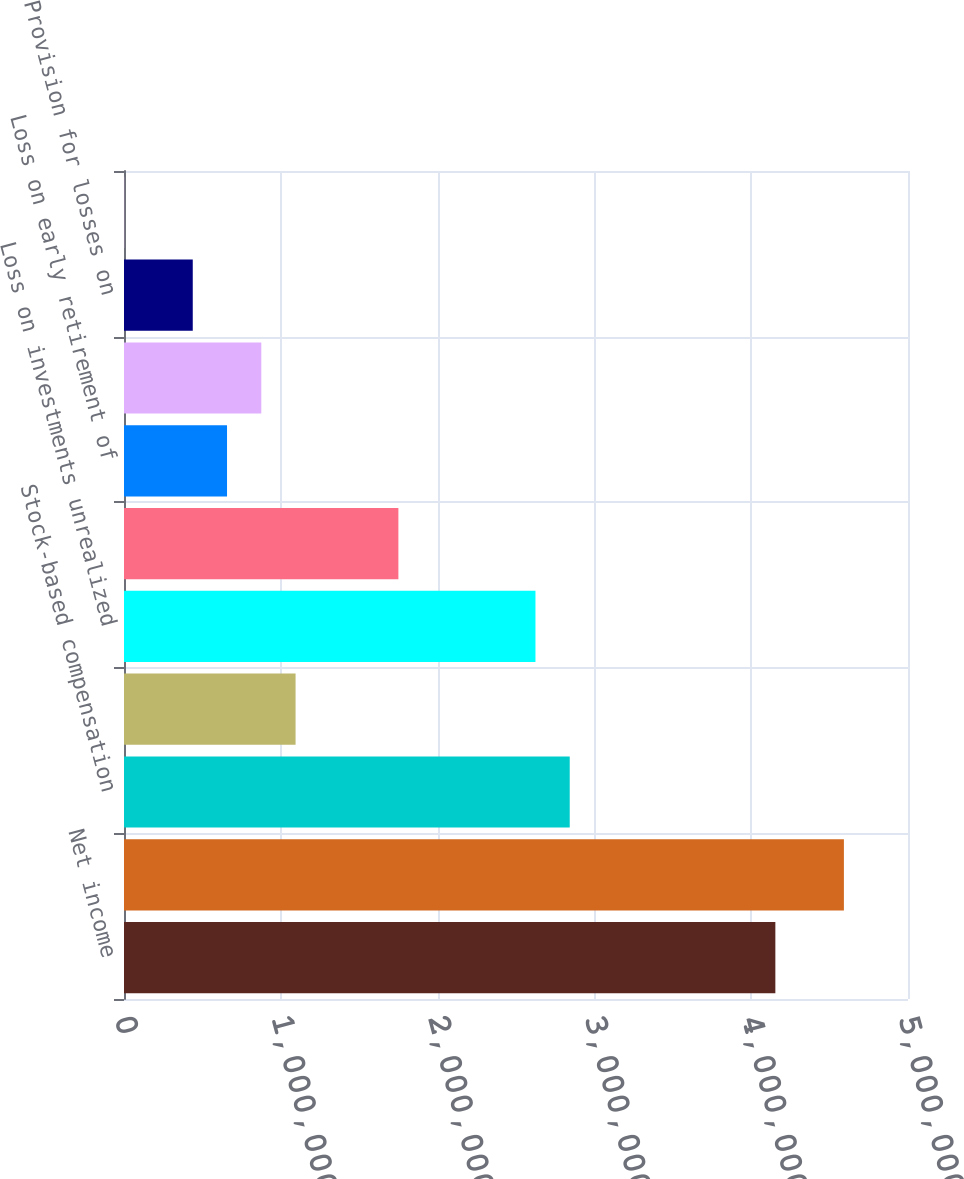Convert chart. <chart><loc_0><loc_0><loc_500><loc_500><bar_chart><fcel>Net income<fcel>Depreciation amortization and<fcel>Stock-based compensation<fcel>Decrease (increase) in<fcel>Loss on investments unrealized<fcel>expenses<fcel>Loss on early retirement of<fcel>interest<fcel>Provision for losses on<fcel>Deferred income taxes<nl><fcel>4.15405e+06<fcel>4.59118e+06<fcel>2.84268e+06<fcel>1.09419e+06<fcel>2.62412e+06<fcel>1.74988e+06<fcel>657069<fcel>875630<fcel>438507<fcel>1384<nl></chart> 